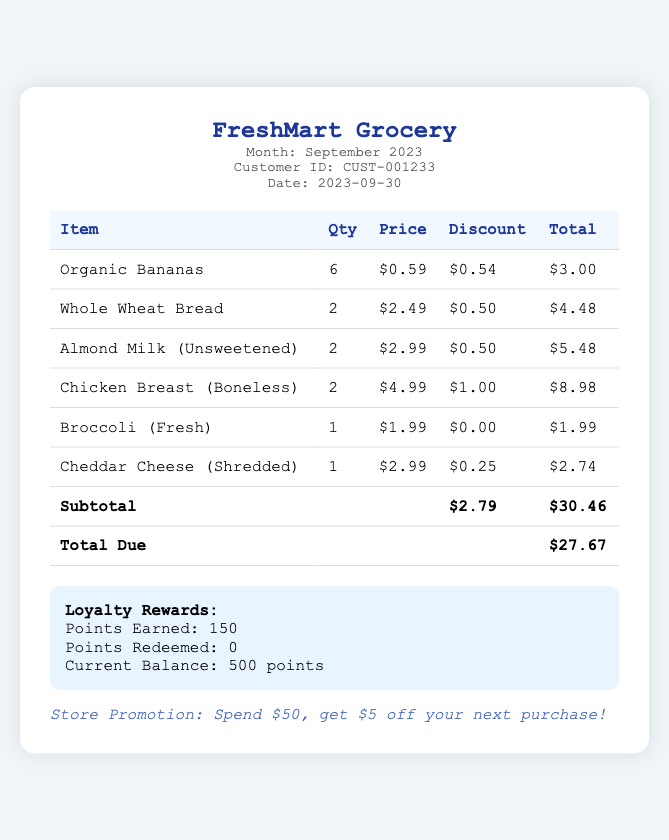What is the store name? The store name is prominently displayed at the top of the bill.
Answer: FreshMart Grocery What is the total due amount? The total due is calculated and shown in the total row at the bottom of the bill.
Answer: $27.67 How many points were earned from loyalty rewards? The points earned are clearly listed in the loyalty rewards section of the document.
Answer: 150 What discount was applied to Organic Bananas? The discount for each item is specified in the discount column for Organic Bananas.
Answer: $0.54 What was the subtotal of the bill? The subtotal is provided in a separate row before the total due in the table.
Answer: $30.46 How many Organic Bananas were purchased? The quantity of each item is indicated in the quantity column of the table.
Answer: 6 What type of milk was bought? The item name in the table specifies the type of milk purchased.
Answer: Almond Milk (Unsweetened) What is the current balance of loyalty points? The current balance of points is mentioned in the loyalty rewards section.
Answer: 500 points What was the discount applied to Chicken Breast? The discount is listed next to the Chicken Breast in the discount column.
Answer: $1.00 